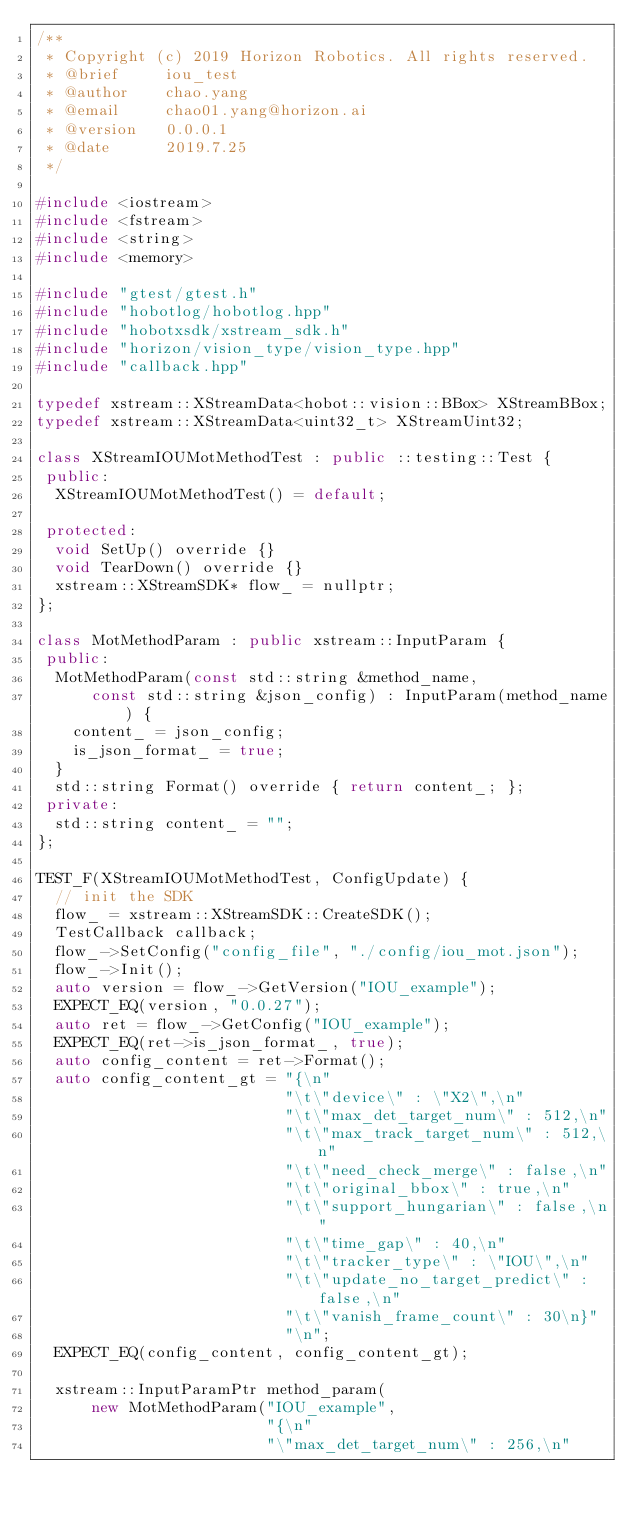Convert code to text. <code><loc_0><loc_0><loc_500><loc_500><_C++_>/**
 * Copyright (c) 2019 Horizon Robotics. All rights reserved.
 * @brief     iou_test
 * @author    chao.yang
 * @email     chao01.yang@horizon.ai
 * @version   0.0.0.1
 * @date      2019.7.25
 */

#include <iostream>
#include <fstream>
#include <string>
#include <memory>

#include "gtest/gtest.h"
#include "hobotlog/hobotlog.hpp"
#include "hobotxsdk/xstream_sdk.h"
#include "horizon/vision_type/vision_type.hpp"
#include "callback.hpp"

typedef xstream::XStreamData<hobot::vision::BBox> XStreamBBox;
typedef xstream::XStreamData<uint32_t> XStreamUint32;

class XStreamIOUMotMethodTest : public ::testing::Test {
 public:
  XStreamIOUMotMethodTest() = default;

 protected:
  void SetUp() override {}
  void TearDown() override {}
  xstream::XStreamSDK* flow_ = nullptr;
};

class MotMethodParam : public xstream::InputParam {
 public:
  MotMethodParam(const std::string &method_name,
      const std::string &json_config) : InputParam(method_name) {
    content_ = json_config;
    is_json_format_ = true;
  }
  std::string Format() override { return content_; };
 private:
  std::string content_ = "";
};

TEST_F(XStreamIOUMotMethodTest, ConfigUpdate) {
  // init the SDK
  flow_ = xstream::XStreamSDK::CreateSDK();
  TestCallback callback;
  flow_->SetConfig("config_file", "./config/iou_mot.json");
  flow_->Init();
  auto version = flow_->GetVersion("IOU_example");
  EXPECT_EQ(version, "0.0.27");
  auto ret = flow_->GetConfig("IOU_example");
  EXPECT_EQ(ret->is_json_format_, true);
  auto config_content = ret->Format();
  auto config_content_gt = "{\n"
                           "\t\"device\" : \"X2\",\n"
                           "\t\"max_det_target_num\" : 512,\n"
                           "\t\"max_track_target_num\" : 512,\n"
                           "\t\"need_check_merge\" : false,\n"
                           "\t\"original_bbox\" : true,\n"
                           "\t\"support_hungarian\" : false,\n"
                           "\t\"time_gap\" : 40,\n"
                           "\t\"tracker_type\" : \"IOU\",\n"
                           "\t\"update_no_target_predict\" : false,\n"
                           "\t\"vanish_frame_count\" : 30\n}"
                           "\n";
  EXPECT_EQ(config_content, config_content_gt);

  xstream::InputParamPtr method_param(
      new MotMethodParam("IOU_example",
                         "{\n"
                         "\"max_det_target_num\" : 256,\n"</code> 